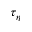<formula> <loc_0><loc_0><loc_500><loc_500>\tau _ { \eta }</formula> 